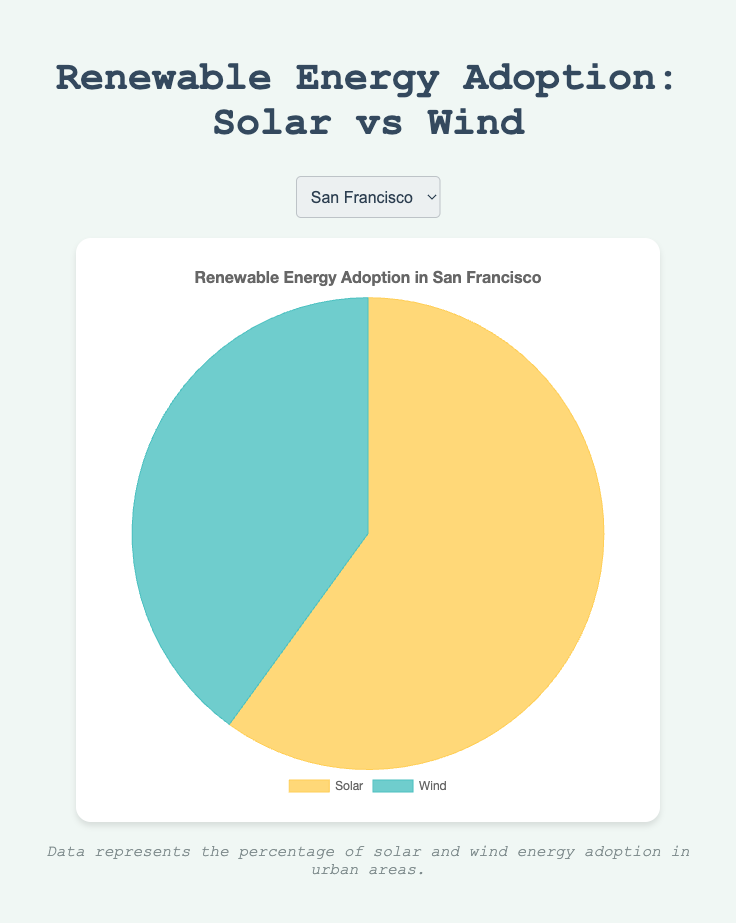Which city has the highest percentage of solar adoption? The chart shows the percentage of solar and wind adoption for each city. To find the city with the highest solar adoption, we compare the solar percentages: San Francisco (60%), Chicago (55%), New York City (70%), Austin (65%), Denver (50%), Boston (58%). New York City has the highest percentage.
Answer: New York City Which city has an equal adoption rate of solar and wind energy? The chart displays the solar and wind adoption percentages for each city. We need to find the city where these percentages are equal. Only Denver has 50% for both solar and wind adoption.
Answer: Denver What is the combined renewable energy capacity (in MW) for San Francisco and New York City? The chart includes the total renewable energy capacity for each city. To find the combined capacity of San Francisco and New York City, we add their capacities: 500 MW (San Francisco) + 800 MW (New York City) = 1300 MW.
Answer: 1300 MW Which city has the lowest percentage of wind adoption? The chart illustrates the wind adoption percentage for each city. To find the lowest wind adoption, we compare the percentages: San Francisco (40%), Chicago (45%), New York City (30%), Austin (35%), Denver (50%), Boston (42%). New York City has the lowest percentage.
Answer: New York City Compare the solar adoption percentages of Austin and Chicago. Which city has a higher rate? The chart indicates the solar adoption percentages for Austin and Chicago. Comparing the percentages: Austin (65%) vs. Chicago (55%), Austin has the higher rate.
Answer: Austin What is the average percentage of wind adoption across all listed cities? To find the average wind adoption percentage, we add the percentages for each city and divide by the number of cities. (40 + 45 + 30 + 35 + 50 + 42) / 6 = 242 / 6 = 40.33%.
Answer: 40.33% Compare the renewable energy capacities of Boston and Denver. Which city has a lower total capacity? The chart includes the total renewable capacities for each city. Comparing Boston (400 MW) and Denver (550 MW), Boston has a lower total capacity.
Answer: Boston What is the difference in solar adoption percentages between New York City and Denver? The chart provides the solar adoption percentages for each city. To find the difference between New York City and Denver: 70% (New York City) - 50% (Denver) = 20%.
Answer: 20% Which city has the closest adoption percentages for solar and wind energy? The chart shows the solar and wind adoption percentages for each city. We need to find the city with the smallest difference between its solar and wind percentages: San Francisco (60-40), Chicago (55-45), New York City (70-30), Austin (65-35), Denver (50-50), Boston (58-42). Denver has the smallest difference (0%).
Answer: Denver 